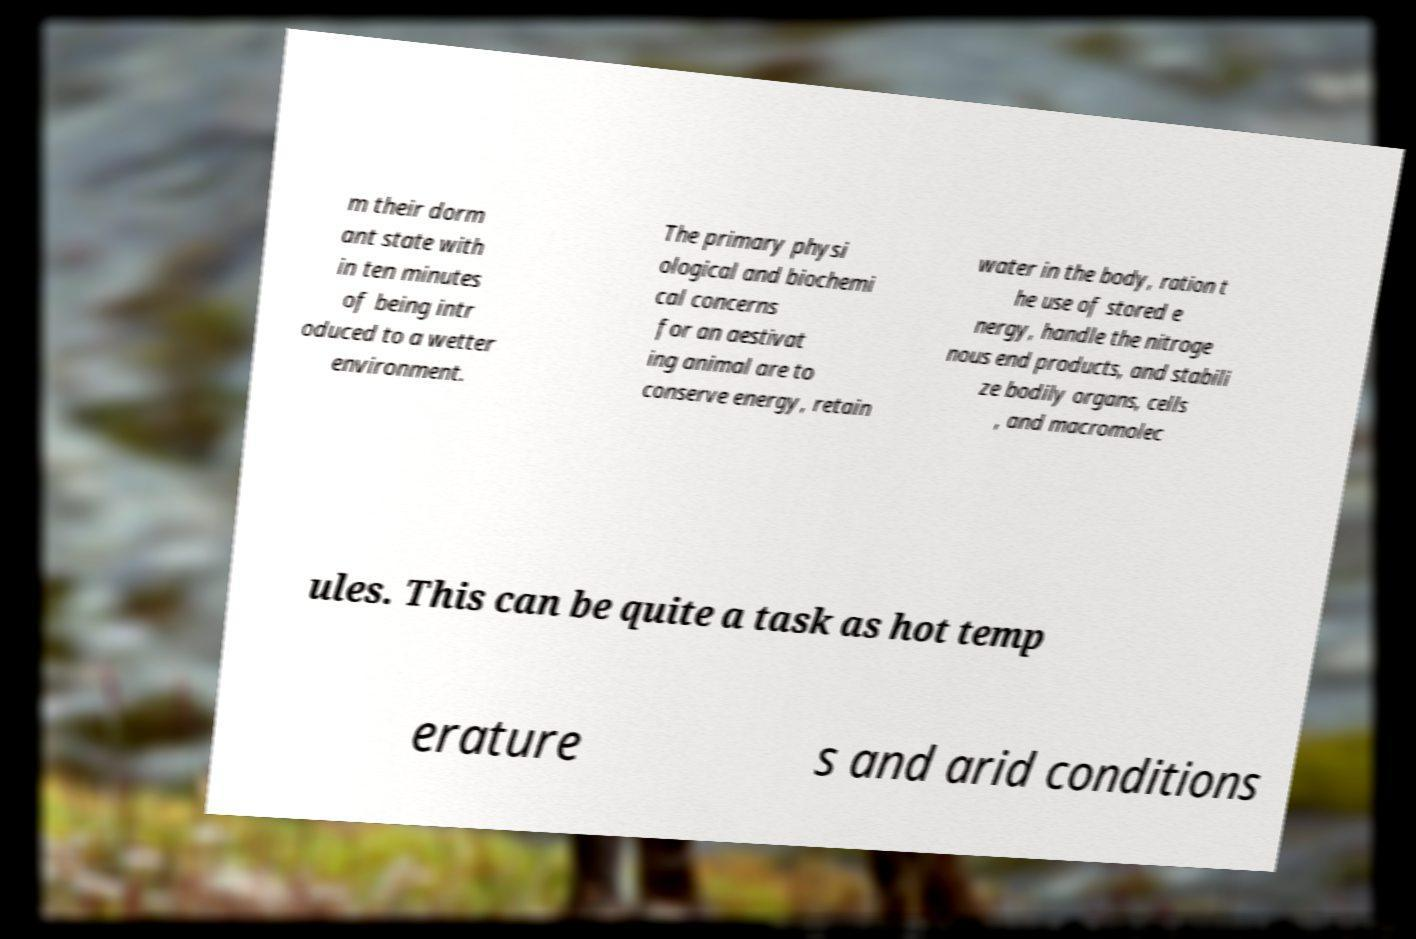Please read and relay the text visible in this image. What does it say? m their dorm ant state with in ten minutes of being intr oduced to a wetter environment. The primary physi ological and biochemi cal concerns for an aestivat ing animal are to conserve energy, retain water in the body, ration t he use of stored e nergy, handle the nitroge nous end products, and stabili ze bodily organs, cells , and macromolec ules. This can be quite a task as hot temp erature s and arid conditions 